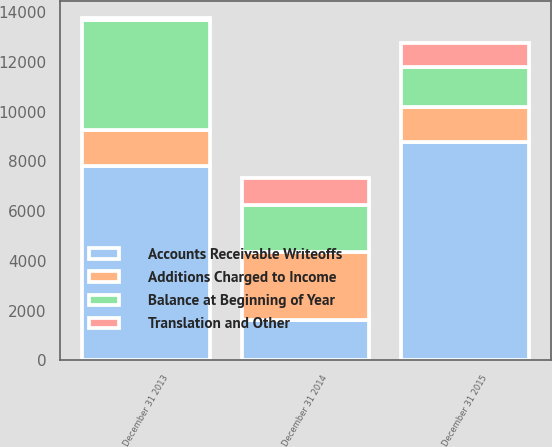<chart> <loc_0><loc_0><loc_500><loc_500><stacked_bar_chart><ecel><fcel>December 31 2015<fcel>December 31 2014<fcel>December 31 2013<nl><fcel>Accounts Receivable Writeoffs<fcel>8783<fcel>1618<fcel>7818<nl><fcel>Balance at Beginning of Year<fcel>1618<fcel>1882<fcel>4414<nl><fcel>Additions Charged to Income<fcel>1387<fcel>2738<fcel>1446<nl><fcel>Translation and Other<fcel>988<fcel>1083<fcel>64<nl></chart> 